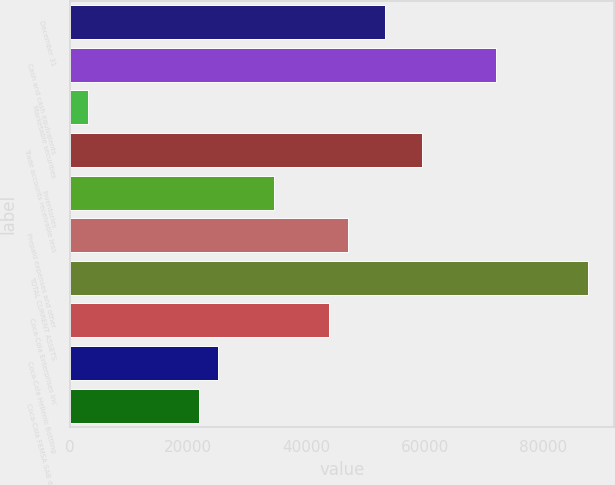Convert chart to OTSL. <chart><loc_0><loc_0><loc_500><loc_500><bar_chart><fcel>December 31<fcel>Cash and cash equivalents<fcel>Marketable securities<fcel>Trade accounts receivable less<fcel>Inventories<fcel>Prepaid expenses and other<fcel>TOTAL CURRENT ASSETS<fcel>Coca-Cola Enterprises Inc<fcel>Coca-Cola Hellenic Bottling<fcel>Coca-Cola FEMSA SAB de CV<nl><fcel>53188.7<fcel>71951.3<fcel>3155.1<fcel>59442.9<fcel>34426.1<fcel>46934.5<fcel>87586.8<fcel>43807.4<fcel>25044.8<fcel>21917.7<nl></chart> 